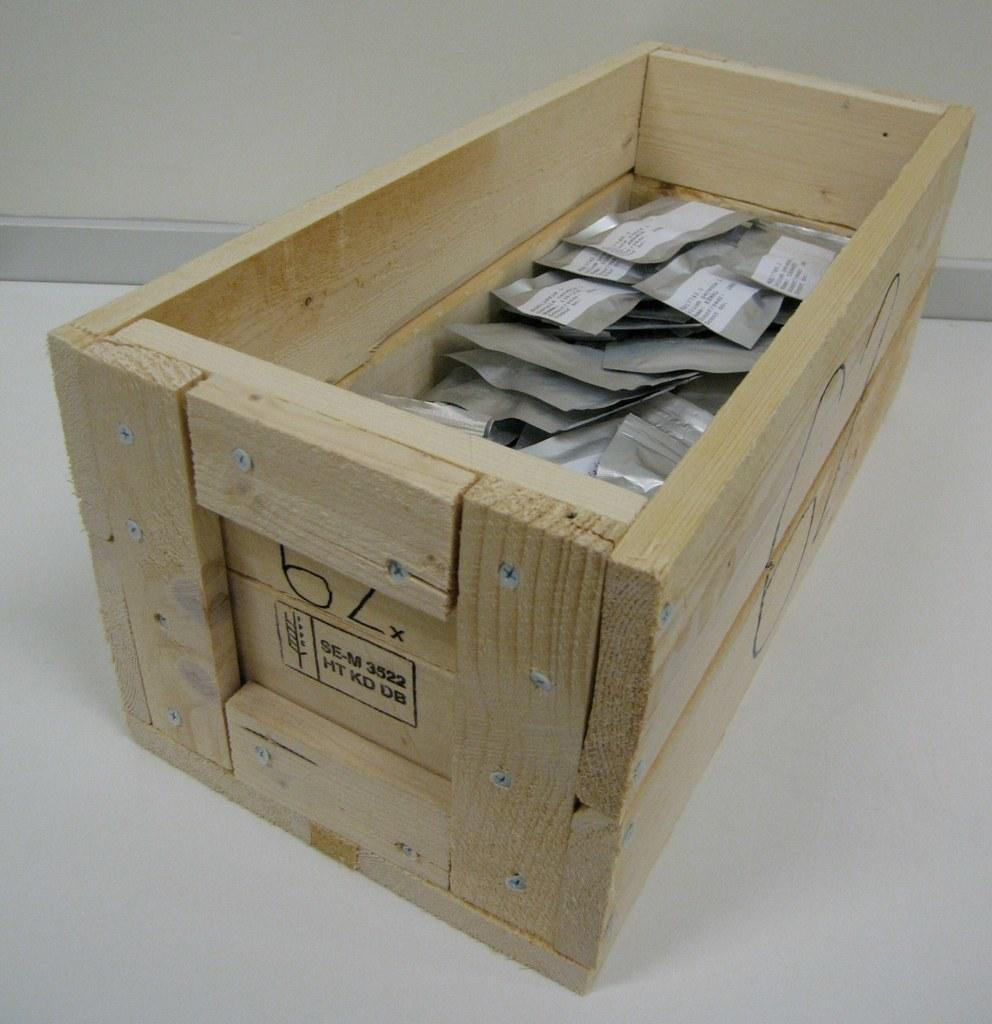<image>
Write a terse but informative summary of the picture. A wooden box has SE-M 3522 printed on the side of it. 